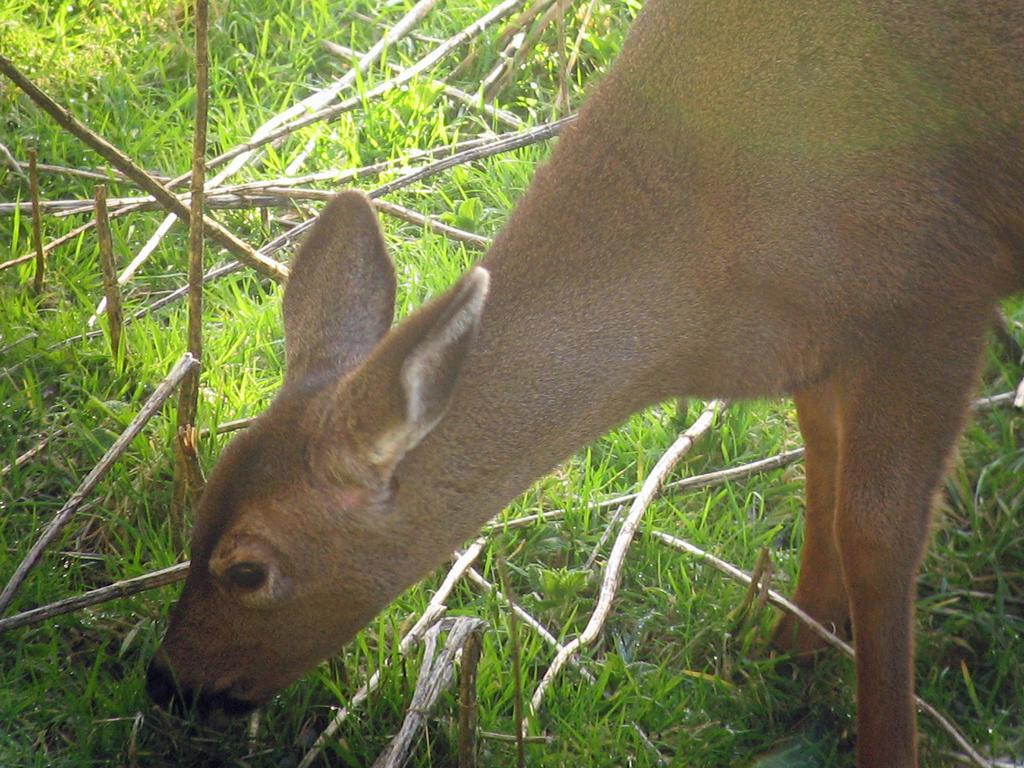In one or two sentences, can you explain what this image depicts? In this image I can see an animal which is in brown color. In front I can see green color grass and few sticks. 